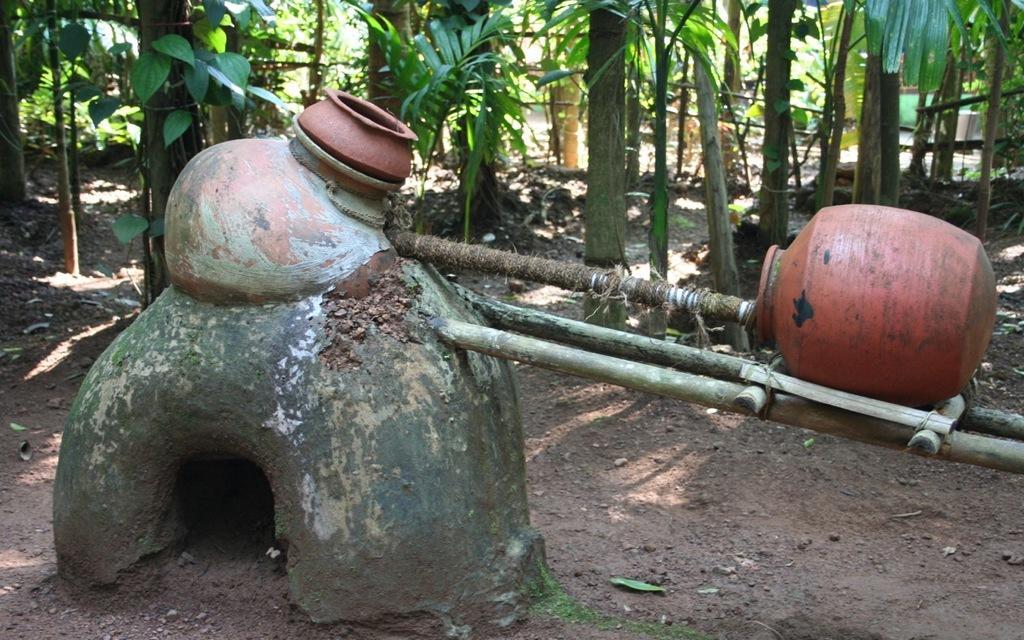Describe this image in one or two sentences. This image consists of pots,sticks and trees. There are leaves which are in green color. 